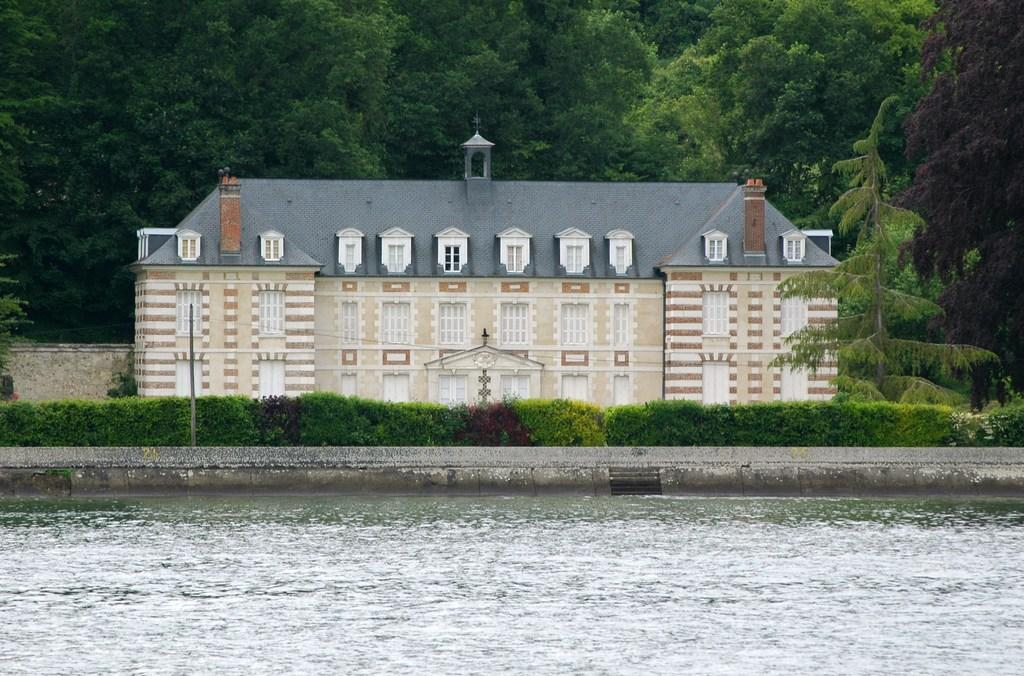What is visible in the foreground of the image? There is water in the foreground of the image. What can be seen in the center of the image? There are plants and trees in the center of the image, as well as a building. What type of vegetation is present in the center and background of the image? There are trees in both the center and background of the image. Who is teaching the plants in the image? There is no indication in the image that anyone is teaching the plants, as plants do not learn or require teaching. Can you see the porter carrying luggage in the image? There is no porter or luggage present in the image. 